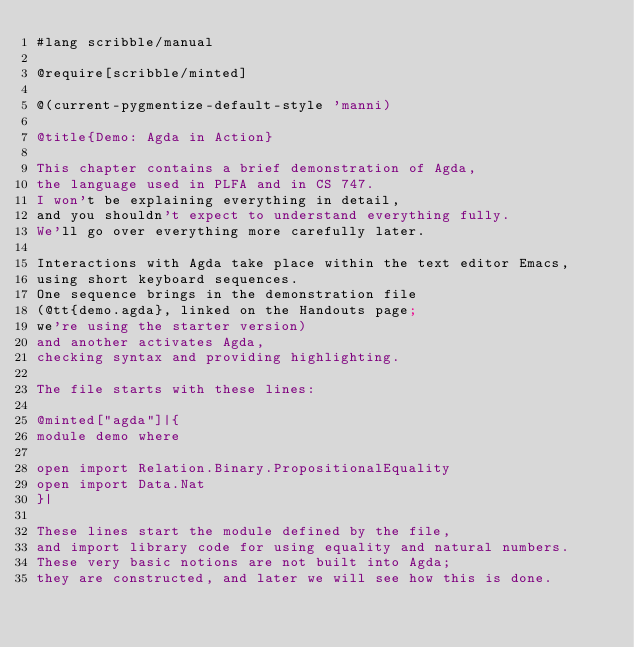<code> <loc_0><loc_0><loc_500><loc_500><_Racket_>#lang scribble/manual

@require[scribble/minted]

@(current-pygmentize-default-style 'manni)

@title{Demo: Agda in Action}

This chapter contains a brief demonstration of Agda,
the language used in PLFA and in CS 747.
I won't be explaining everything in detail,
and you shouldn't expect to understand everything fully.
We'll go over everything more carefully later.

Interactions with Agda take place within the text editor Emacs,
using short keyboard sequences.
One sequence brings in the demonstration file
(@tt{demo.agda}, linked on the Handouts page;
we're using the starter version)
and another activates Agda,
checking syntax and providing highlighting.

The file starts with these lines:

@minted["agda"]|{
module demo where

open import Relation.Binary.PropositionalEquality
open import Data.Nat
}|

These lines start the module defined by the file,
and import library code for using equality and natural numbers.
These very basic notions are not built into Agda;
they are constructed, and later we will see how this is done.
</code> 